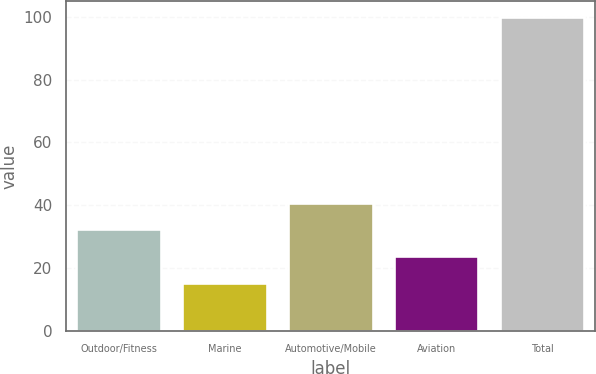Convert chart to OTSL. <chart><loc_0><loc_0><loc_500><loc_500><bar_chart><fcel>Outdoor/Fitness<fcel>Marine<fcel>Automotive/Mobile<fcel>Aviation<fcel>Total<nl><fcel>32.32<fcel>15.4<fcel>40.78<fcel>23.86<fcel>100<nl></chart> 